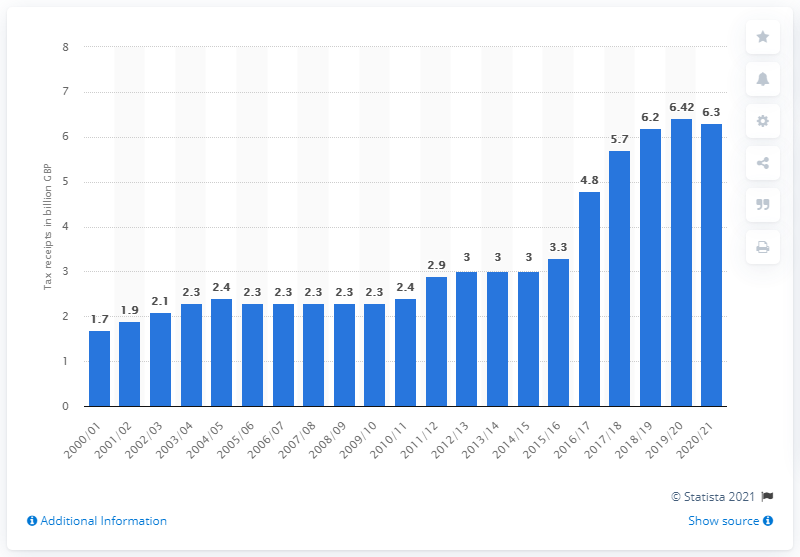Draw attention to some important aspects in this diagram. According to the most recent statistics, insurance premiums in the United Kingdom generated approximately 6.3 billion pounds in tax revenue. The amount of tax revenue generated from insurance premiums in the UK during the 2000/01 fiscal year was approximately 1.7 billion pounds. 